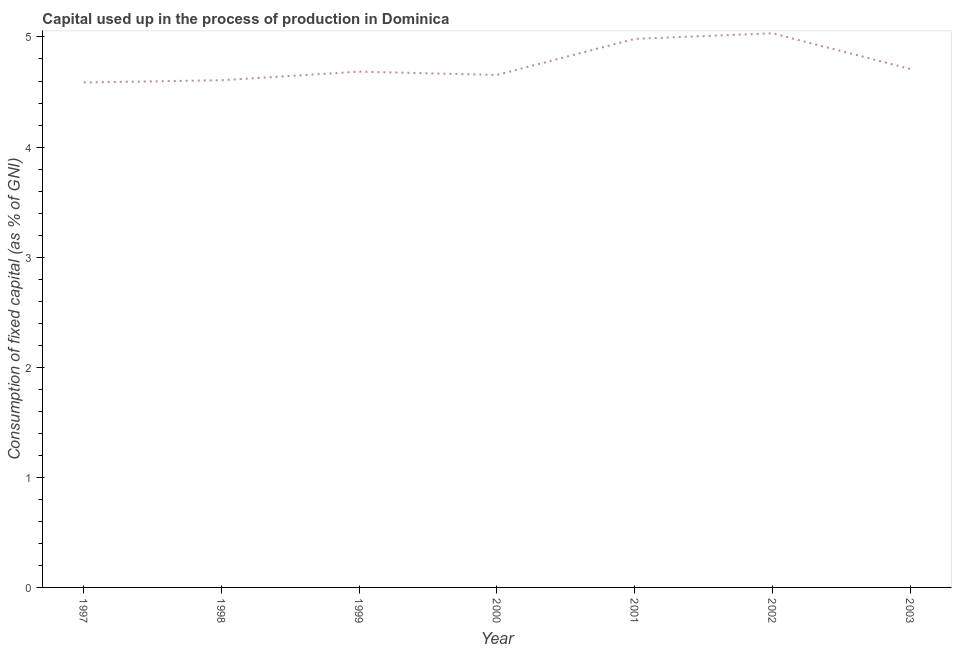What is the consumption of fixed capital in 2002?
Provide a short and direct response. 5.03. Across all years, what is the maximum consumption of fixed capital?
Your answer should be very brief. 5.03. Across all years, what is the minimum consumption of fixed capital?
Your response must be concise. 4.59. In which year was the consumption of fixed capital maximum?
Ensure brevity in your answer.  2002. What is the sum of the consumption of fixed capital?
Ensure brevity in your answer.  33.26. What is the difference between the consumption of fixed capital in 1998 and 1999?
Provide a short and direct response. -0.08. What is the average consumption of fixed capital per year?
Your answer should be very brief. 4.75. What is the median consumption of fixed capital?
Make the answer very short. 4.69. In how many years, is the consumption of fixed capital greater than 4.2 %?
Provide a succinct answer. 7. What is the ratio of the consumption of fixed capital in 1997 to that in 2002?
Your answer should be very brief. 0.91. Is the consumption of fixed capital in 1997 less than that in 1999?
Offer a terse response. Yes. Is the difference between the consumption of fixed capital in 2000 and 2003 greater than the difference between any two years?
Give a very brief answer. No. What is the difference between the highest and the second highest consumption of fixed capital?
Ensure brevity in your answer.  0.05. What is the difference between the highest and the lowest consumption of fixed capital?
Give a very brief answer. 0.45. Does the consumption of fixed capital monotonically increase over the years?
Give a very brief answer. No. How many lines are there?
Your answer should be compact. 1. How many years are there in the graph?
Ensure brevity in your answer.  7. Are the values on the major ticks of Y-axis written in scientific E-notation?
Make the answer very short. No. Does the graph contain grids?
Provide a succinct answer. No. What is the title of the graph?
Your answer should be compact. Capital used up in the process of production in Dominica. What is the label or title of the X-axis?
Make the answer very short. Year. What is the label or title of the Y-axis?
Your answer should be compact. Consumption of fixed capital (as % of GNI). What is the Consumption of fixed capital (as % of GNI) in 1997?
Provide a succinct answer. 4.59. What is the Consumption of fixed capital (as % of GNI) of 1998?
Your response must be concise. 4.61. What is the Consumption of fixed capital (as % of GNI) of 1999?
Give a very brief answer. 4.69. What is the Consumption of fixed capital (as % of GNI) in 2000?
Give a very brief answer. 4.65. What is the Consumption of fixed capital (as % of GNI) in 2001?
Your answer should be compact. 4.98. What is the Consumption of fixed capital (as % of GNI) of 2002?
Make the answer very short. 5.03. What is the Consumption of fixed capital (as % of GNI) in 2003?
Offer a terse response. 4.71. What is the difference between the Consumption of fixed capital (as % of GNI) in 1997 and 1998?
Make the answer very short. -0.02. What is the difference between the Consumption of fixed capital (as % of GNI) in 1997 and 1999?
Give a very brief answer. -0.1. What is the difference between the Consumption of fixed capital (as % of GNI) in 1997 and 2000?
Ensure brevity in your answer.  -0.07. What is the difference between the Consumption of fixed capital (as % of GNI) in 1997 and 2001?
Give a very brief answer. -0.4. What is the difference between the Consumption of fixed capital (as % of GNI) in 1997 and 2002?
Give a very brief answer. -0.45. What is the difference between the Consumption of fixed capital (as % of GNI) in 1997 and 2003?
Ensure brevity in your answer.  -0.12. What is the difference between the Consumption of fixed capital (as % of GNI) in 1998 and 1999?
Offer a terse response. -0.08. What is the difference between the Consumption of fixed capital (as % of GNI) in 1998 and 2000?
Provide a succinct answer. -0.05. What is the difference between the Consumption of fixed capital (as % of GNI) in 1998 and 2001?
Ensure brevity in your answer.  -0.38. What is the difference between the Consumption of fixed capital (as % of GNI) in 1998 and 2002?
Give a very brief answer. -0.43. What is the difference between the Consumption of fixed capital (as % of GNI) in 1998 and 2003?
Make the answer very short. -0.1. What is the difference between the Consumption of fixed capital (as % of GNI) in 1999 and 2000?
Make the answer very short. 0.03. What is the difference between the Consumption of fixed capital (as % of GNI) in 1999 and 2001?
Your answer should be compact. -0.3. What is the difference between the Consumption of fixed capital (as % of GNI) in 1999 and 2002?
Your answer should be compact. -0.35. What is the difference between the Consumption of fixed capital (as % of GNI) in 1999 and 2003?
Offer a very short reply. -0.02. What is the difference between the Consumption of fixed capital (as % of GNI) in 2000 and 2001?
Keep it short and to the point. -0.33. What is the difference between the Consumption of fixed capital (as % of GNI) in 2000 and 2002?
Provide a short and direct response. -0.38. What is the difference between the Consumption of fixed capital (as % of GNI) in 2000 and 2003?
Give a very brief answer. -0.05. What is the difference between the Consumption of fixed capital (as % of GNI) in 2001 and 2002?
Offer a very short reply. -0.05. What is the difference between the Consumption of fixed capital (as % of GNI) in 2001 and 2003?
Your answer should be very brief. 0.27. What is the difference between the Consumption of fixed capital (as % of GNI) in 2002 and 2003?
Make the answer very short. 0.32. What is the ratio of the Consumption of fixed capital (as % of GNI) in 1997 to that in 2000?
Offer a very short reply. 0.98. What is the ratio of the Consumption of fixed capital (as % of GNI) in 1997 to that in 2001?
Keep it short and to the point. 0.92. What is the ratio of the Consumption of fixed capital (as % of GNI) in 1997 to that in 2002?
Offer a terse response. 0.91. What is the ratio of the Consumption of fixed capital (as % of GNI) in 1998 to that in 2000?
Provide a short and direct response. 0.99. What is the ratio of the Consumption of fixed capital (as % of GNI) in 1998 to that in 2001?
Offer a terse response. 0.93. What is the ratio of the Consumption of fixed capital (as % of GNI) in 1998 to that in 2002?
Provide a succinct answer. 0.92. What is the ratio of the Consumption of fixed capital (as % of GNI) in 1998 to that in 2003?
Offer a very short reply. 0.98. What is the ratio of the Consumption of fixed capital (as % of GNI) in 1999 to that in 2000?
Keep it short and to the point. 1.01. What is the ratio of the Consumption of fixed capital (as % of GNI) in 1999 to that in 2002?
Your answer should be very brief. 0.93. What is the ratio of the Consumption of fixed capital (as % of GNI) in 2000 to that in 2001?
Your answer should be compact. 0.93. What is the ratio of the Consumption of fixed capital (as % of GNI) in 2000 to that in 2002?
Provide a succinct answer. 0.93. What is the ratio of the Consumption of fixed capital (as % of GNI) in 2000 to that in 2003?
Keep it short and to the point. 0.99. What is the ratio of the Consumption of fixed capital (as % of GNI) in 2001 to that in 2002?
Keep it short and to the point. 0.99. What is the ratio of the Consumption of fixed capital (as % of GNI) in 2001 to that in 2003?
Provide a short and direct response. 1.06. What is the ratio of the Consumption of fixed capital (as % of GNI) in 2002 to that in 2003?
Ensure brevity in your answer.  1.07. 